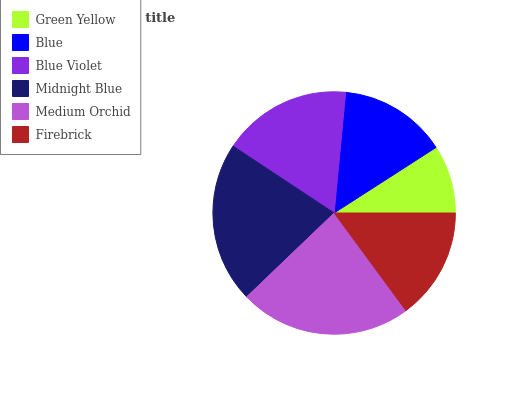Is Green Yellow the minimum?
Answer yes or no. Yes. Is Medium Orchid the maximum?
Answer yes or no. Yes. Is Blue the minimum?
Answer yes or no. No. Is Blue the maximum?
Answer yes or no. No. Is Blue greater than Green Yellow?
Answer yes or no. Yes. Is Green Yellow less than Blue?
Answer yes or no. Yes. Is Green Yellow greater than Blue?
Answer yes or no. No. Is Blue less than Green Yellow?
Answer yes or no. No. Is Blue Violet the high median?
Answer yes or no. Yes. Is Firebrick the low median?
Answer yes or no. Yes. Is Firebrick the high median?
Answer yes or no. No. Is Medium Orchid the low median?
Answer yes or no. No. 